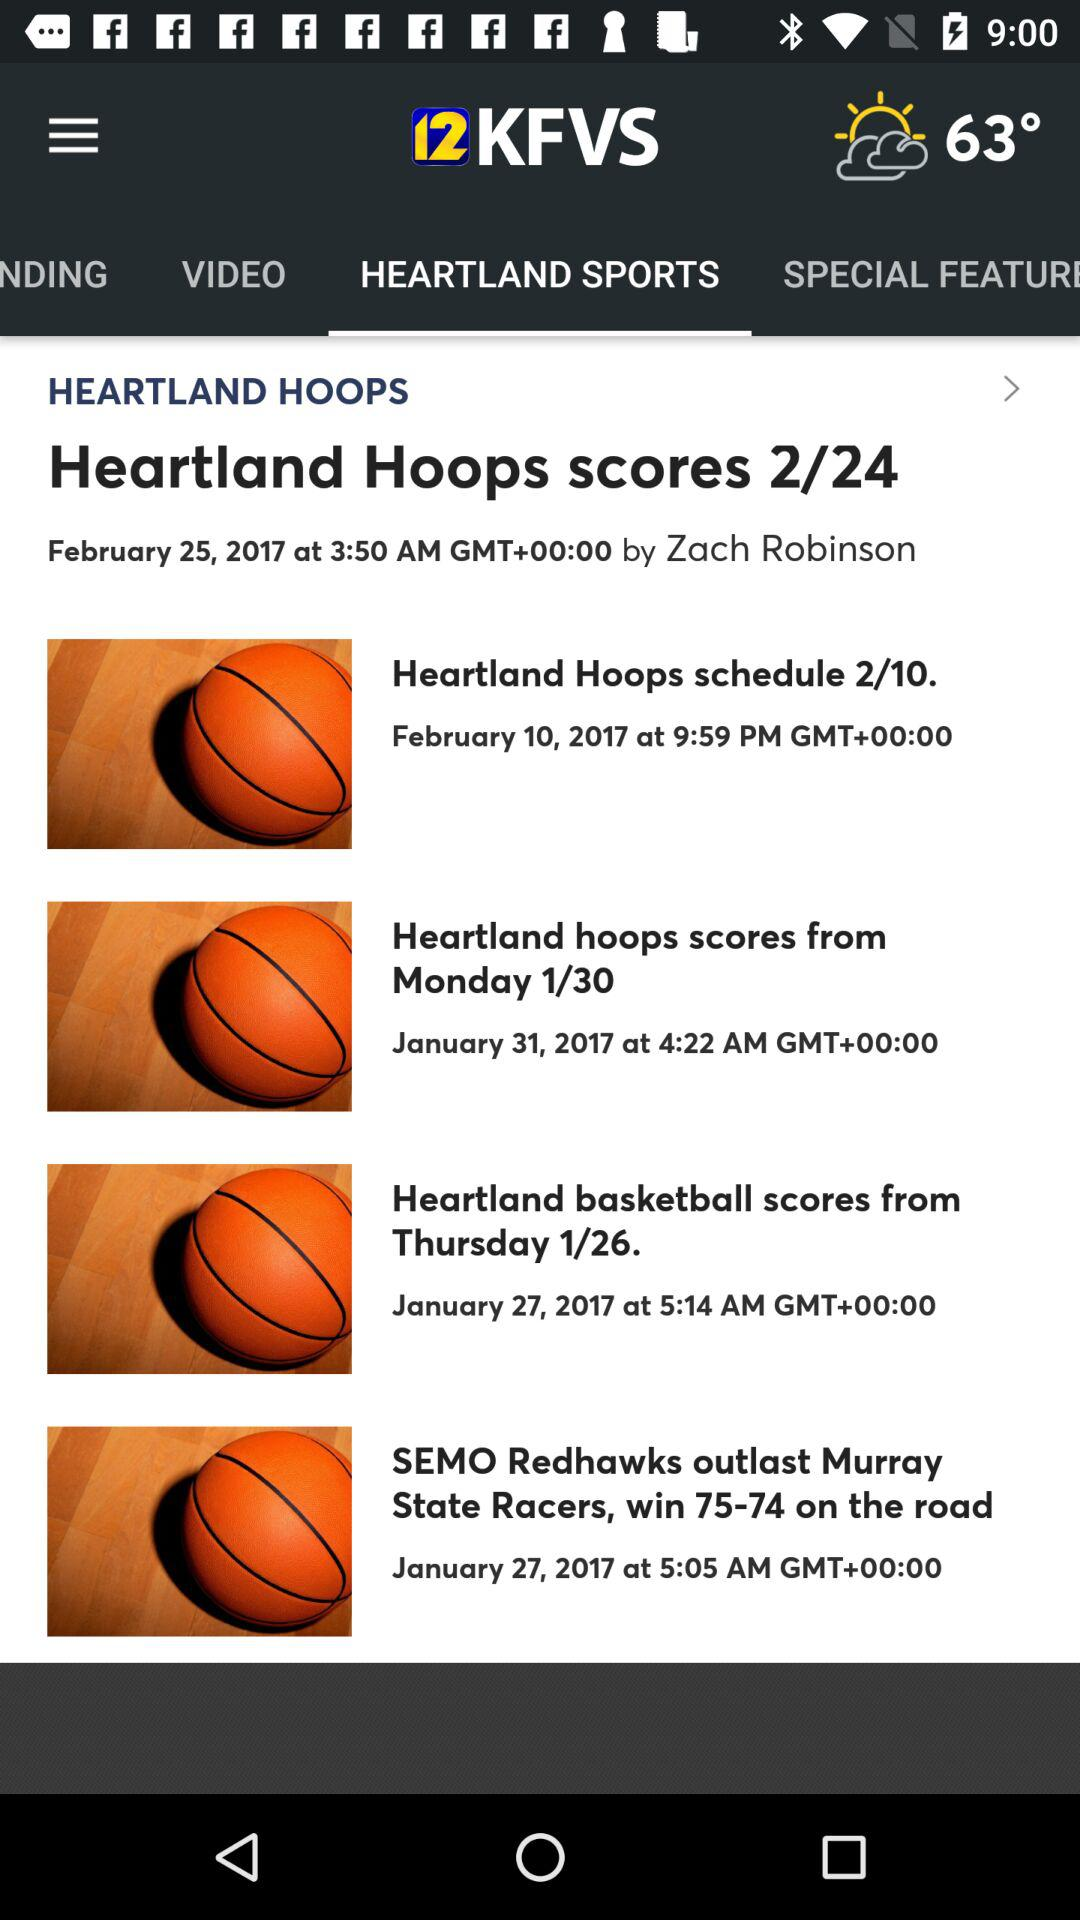What are the scores out of total score?
When the provided information is insufficient, respond with <no answer>. <no answer> 